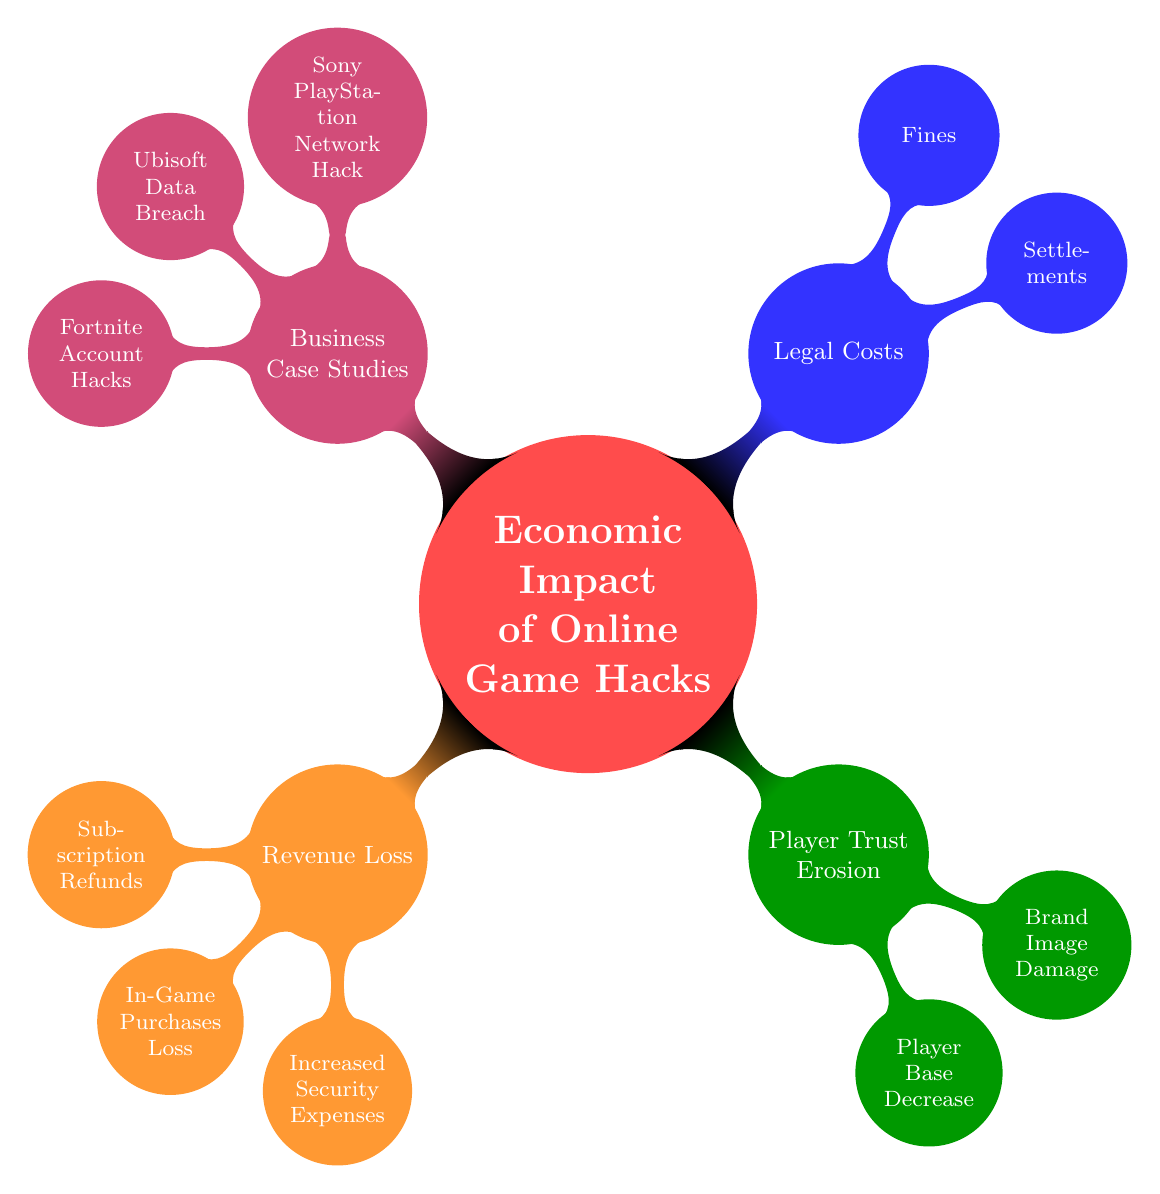What is the main topic of the diagram? The diagram's central node clearly states that the main topic is "Economic Impact of Online Game Hacks," which can be read directly from the title node.
Answer: Economic Impact of Online Game Hacks How many main categories are displayed in this diagram? The diagram has four main categories branching directly from the central node, which can be counted: Revenue Loss, Player Trust Erosion, Legal Costs, and Business Case Studies.
Answer: 4 What does the category "Revenue Loss" consist of? Under the category "Revenue Loss," there are three sub-nodes: Subscription Refunds, In-Game Purchases Loss, and Increased Security Expenses, which define its components.
Answer: Subscription Refunds, In-Game Purchases Loss, Increased Security Expenses Which business case study is related to legal costs? The diagram presents "Settlements" and "Fines" under the Legal Costs category but does not specify which business case studies are linked to these legal aspects. However, since the Business Case Studies node includes multiple notable companies, any applicable case could be inferred; yet only Sony is associated with legal costs in the examples given.
Answer: Sony PlayStation Network Hack How is "Player Trust Erosion" impacted by "Brand Image Damage"? The impact is thematic and indirect: damage to a brand image can lead to erosion of player trust, which is indicated by the hierarchical structure showing Player Trust Erosion as a direct consequence of Brand Image Damage in the diagram. Therefore, it illustrates a cause-and-effect relationship between the two.
Answer: Erosion of player trust Which node follows "Legal Costs" in this diagram? The nodes generally branch out and list prominent elements following "Legal Costs"; however, no additional nodes come after "Legal Costs" as it is a sub-category and only consists of sub-nodes itself such as Settlements and Fines. Thus, it is somewhat standalone in context.
Answer: None 